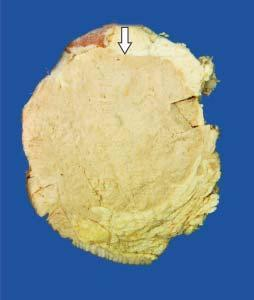s the tumour somewhat delineated from the adjacent breast parenchyma as compared to irregular margin of idc?
Answer the question using a single word or phrase. Yes 